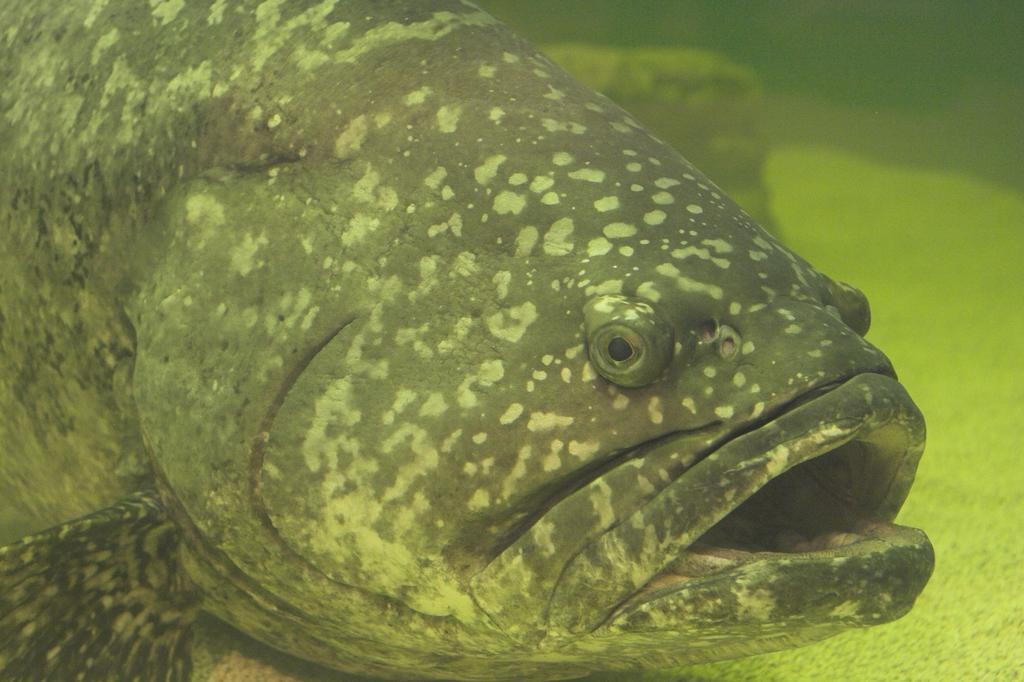Can you describe this image briefly? In this image we can see a fish in the water. In the background there are objects under the water. 